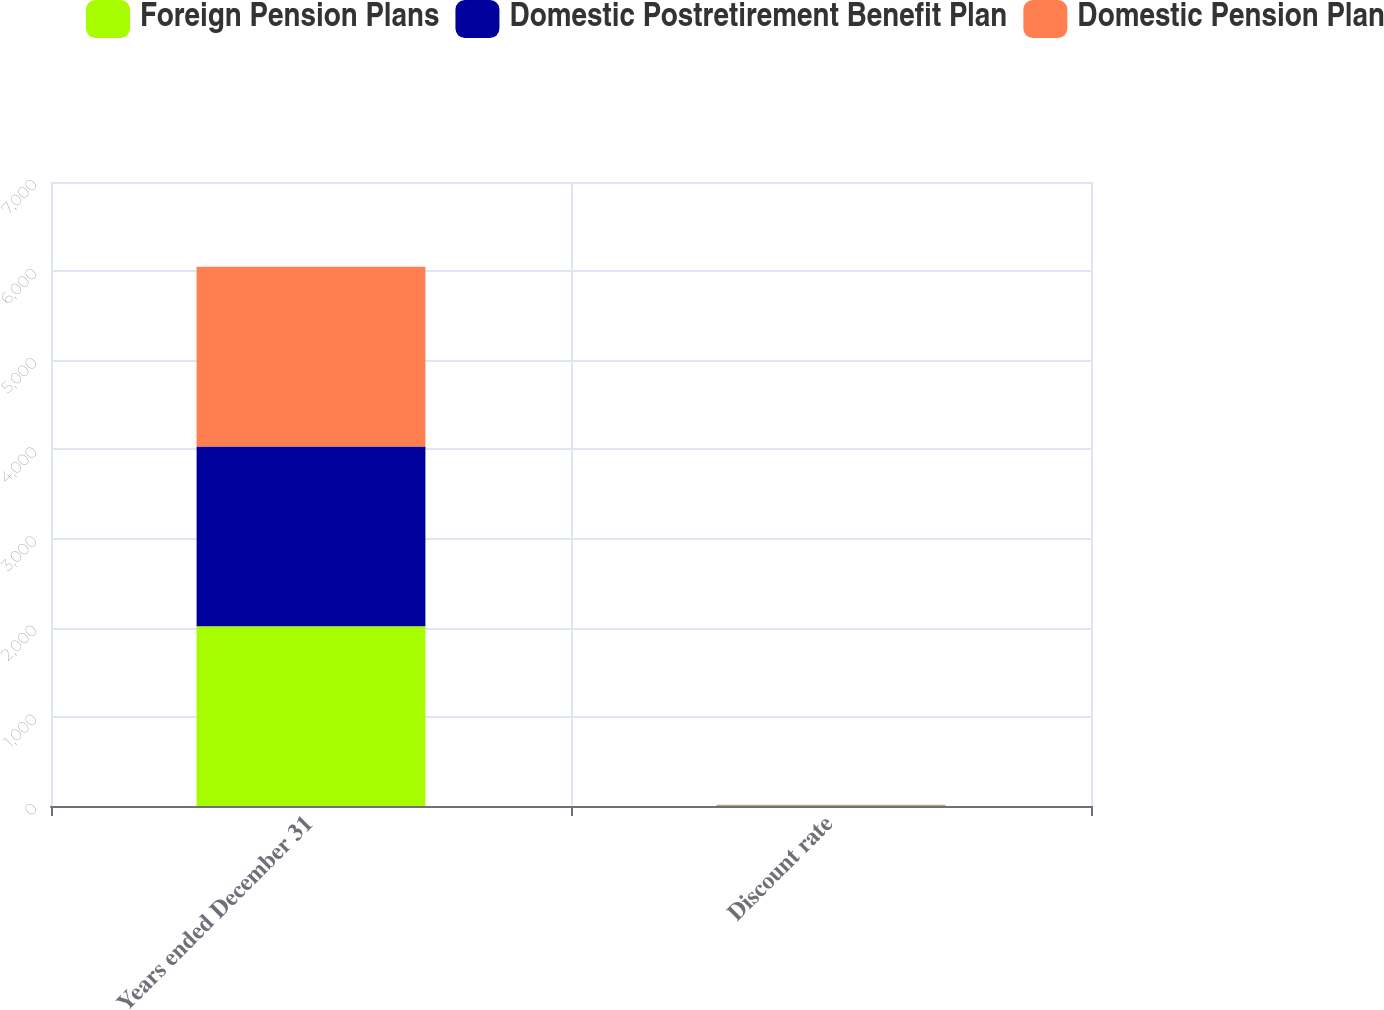Convert chart to OTSL. <chart><loc_0><loc_0><loc_500><loc_500><stacked_bar_chart><ecel><fcel>Years ended December 31<fcel>Discount rate<nl><fcel>Foreign Pension Plans<fcel>2016<fcel>4.8<nl><fcel>Domestic Postretirement Benefit Plan<fcel>2016<fcel>3.61<nl><fcel>Domestic Pension Plan<fcel>2016<fcel>4.65<nl></chart> 